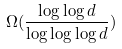Convert formula to latex. <formula><loc_0><loc_0><loc_500><loc_500>\Omega ( \frac { \log \log d } { \log \log \log d } )</formula> 